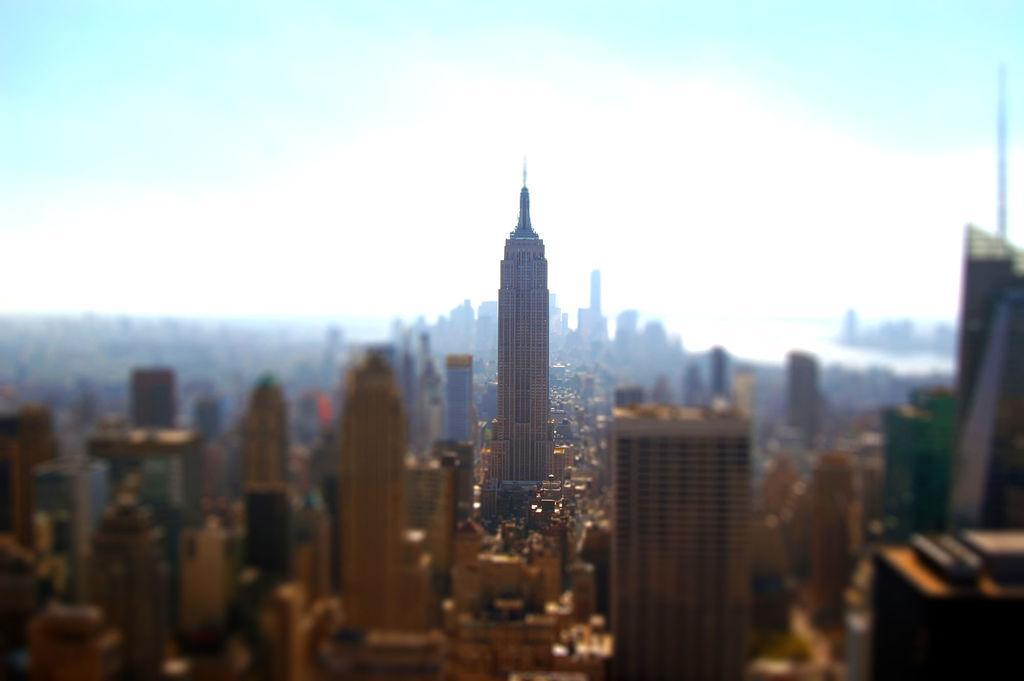Please provide a concise description of this image. In the picture I can see buildings and the sky. The background of the image is blurred. 